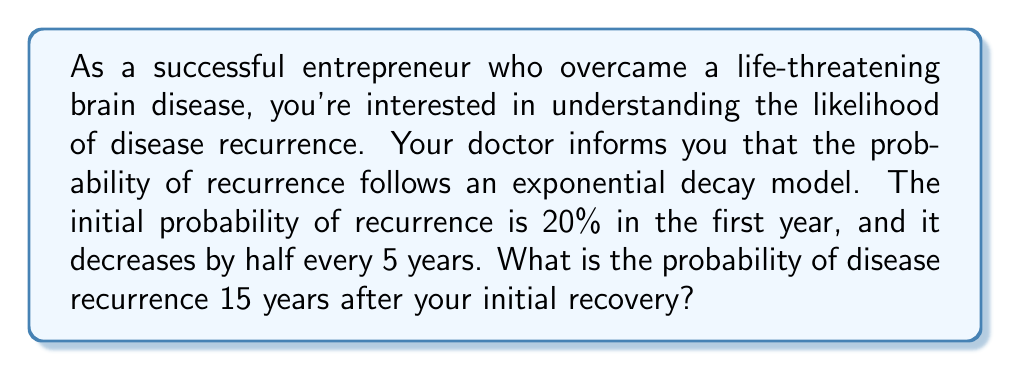Provide a solution to this math problem. To solve this problem, we need to use the exponential decay formula and apply it to the given information. Let's break it down step by step:

1. The exponential decay formula is:
   $$P(t) = P_0 \cdot (1/2)^{t/h}$$
   Where:
   $P(t)$ is the probability at time $t$
   $P_0$ is the initial probability
   $t$ is the time elapsed
   $h$ is the half-life (time it takes for the probability to decrease by half)

2. Given information:
   $P_0 = 20\% = 0.20$
   $h = 5$ years
   $t = 15$ years

3. Substituting these values into the formula:
   $$P(15) = 0.20 \cdot (1/2)^{15/5}$$

4. Simplify the exponent:
   $$P(15) = 0.20 \cdot (1/2)^3$$

5. Calculate $(1/2)^3$:
   $$(1/2)^3 = 1/8 = 0.125$$

6. Multiply:
   $$P(15) = 0.20 \cdot 0.125 = 0.025$$

7. Convert to percentage:
   $$P(15) = 0.025 \cdot 100\% = 2.5\%$$

Therefore, the probability of disease recurrence 15 years after your initial recovery is 2.5%.
Answer: 2.5% 